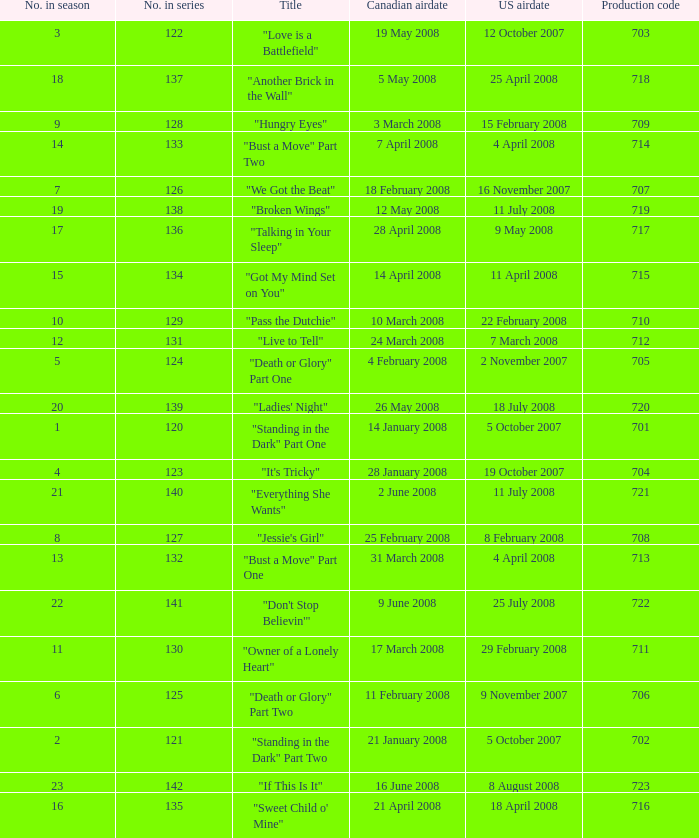The canadian airdate of 17 march 2008 had how many numbers in the season? 1.0. 